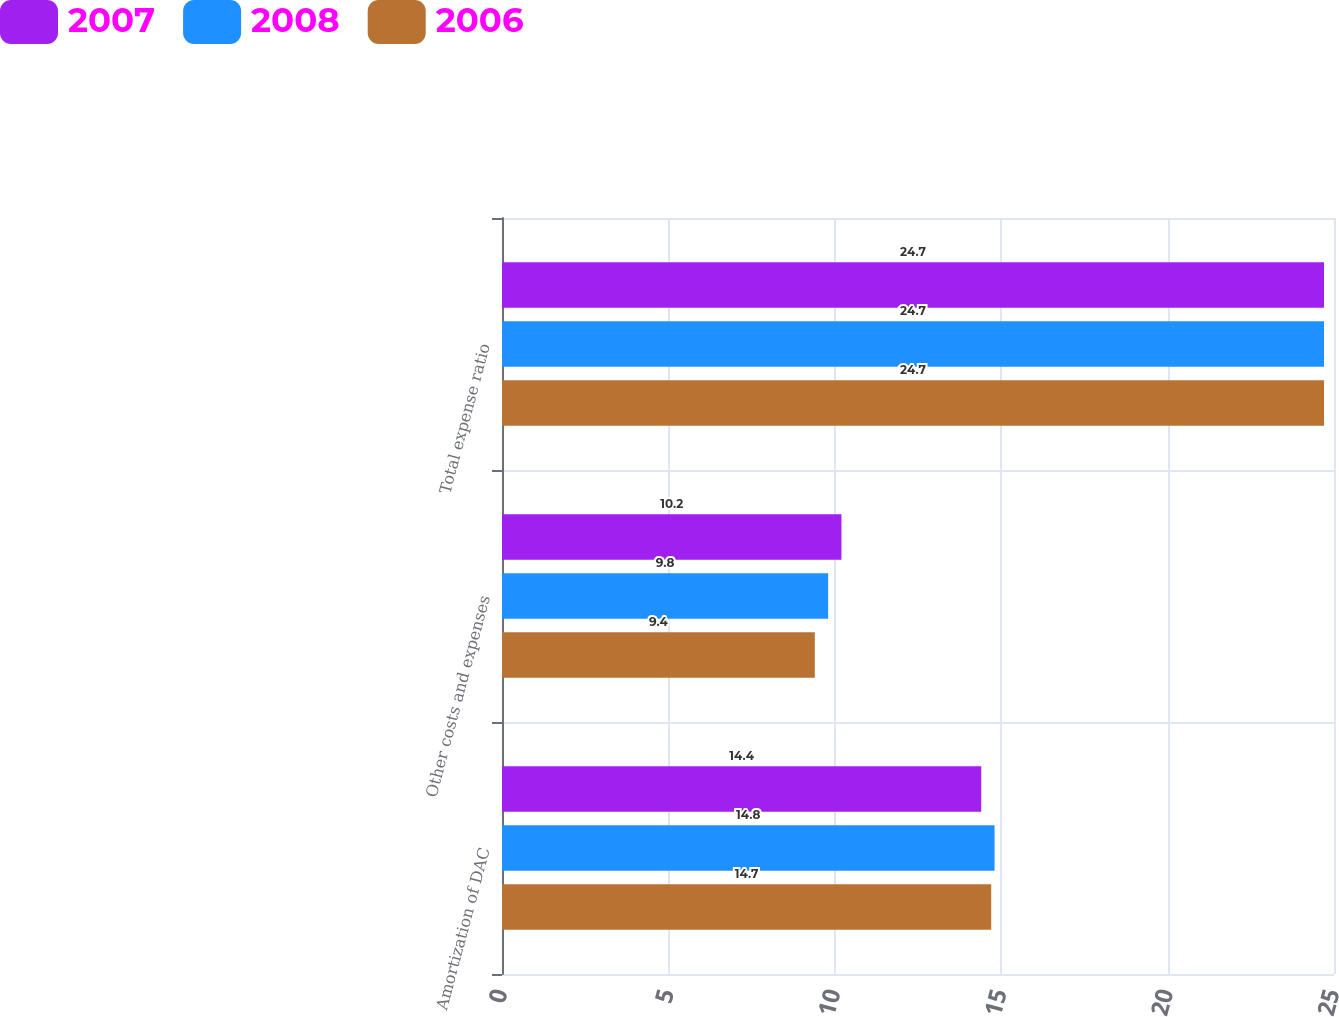<chart> <loc_0><loc_0><loc_500><loc_500><stacked_bar_chart><ecel><fcel>Amortization of DAC<fcel>Other costs and expenses<fcel>Total expense ratio<nl><fcel>2007<fcel>14.4<fcel>10.2<fcel>24.7<nl><fcel>2008<fcel>14.8<fcel>9.8<fcel>24.7<nl><fcel>2006<fcel>14.7<fcel>9.4<fcel>24.7<nl></chart> 